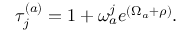<formula> <loc_0><loc_0><loc_500><loc_500>\tau _ { j } ^ { ( a ) } = 1 + \omega _ { a } ^ { j } e ^ { ( \Omega _ { a } + \rho ) } .</formula> 